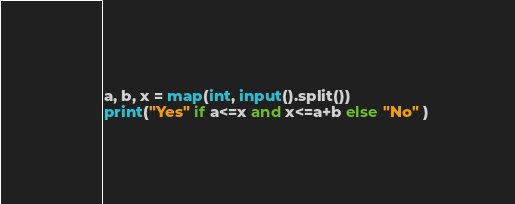Convert code to text. <code><loc_0><loc_0><loc_500><loc_500><_Python_>a, b, x = map(int, input().split())
print("Yes" if a<=x and x<=a+b else "No" )</code> 